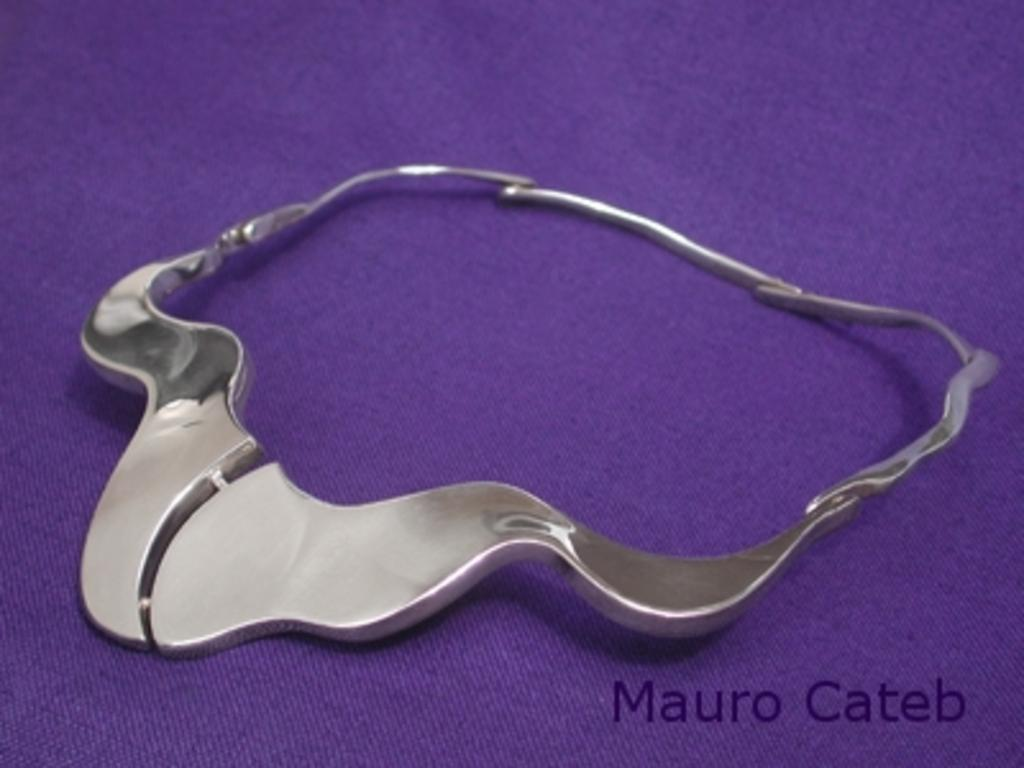What is the main object in the center of the image? There is a carpet in the center of the image. What color is the carpet? The carpet is violet in color. What type of object can be seen on the carpet? There is a steel object on the carpet. Where is the text located in the image? The text is in the bottom right side of the image. How many passengers are visible in the image? There are no passengers present in the image. What type of letters can be seen on the steel object? There is no mention of letters on the steel object in the provided facts, so we cannot determine if any letters are present. 